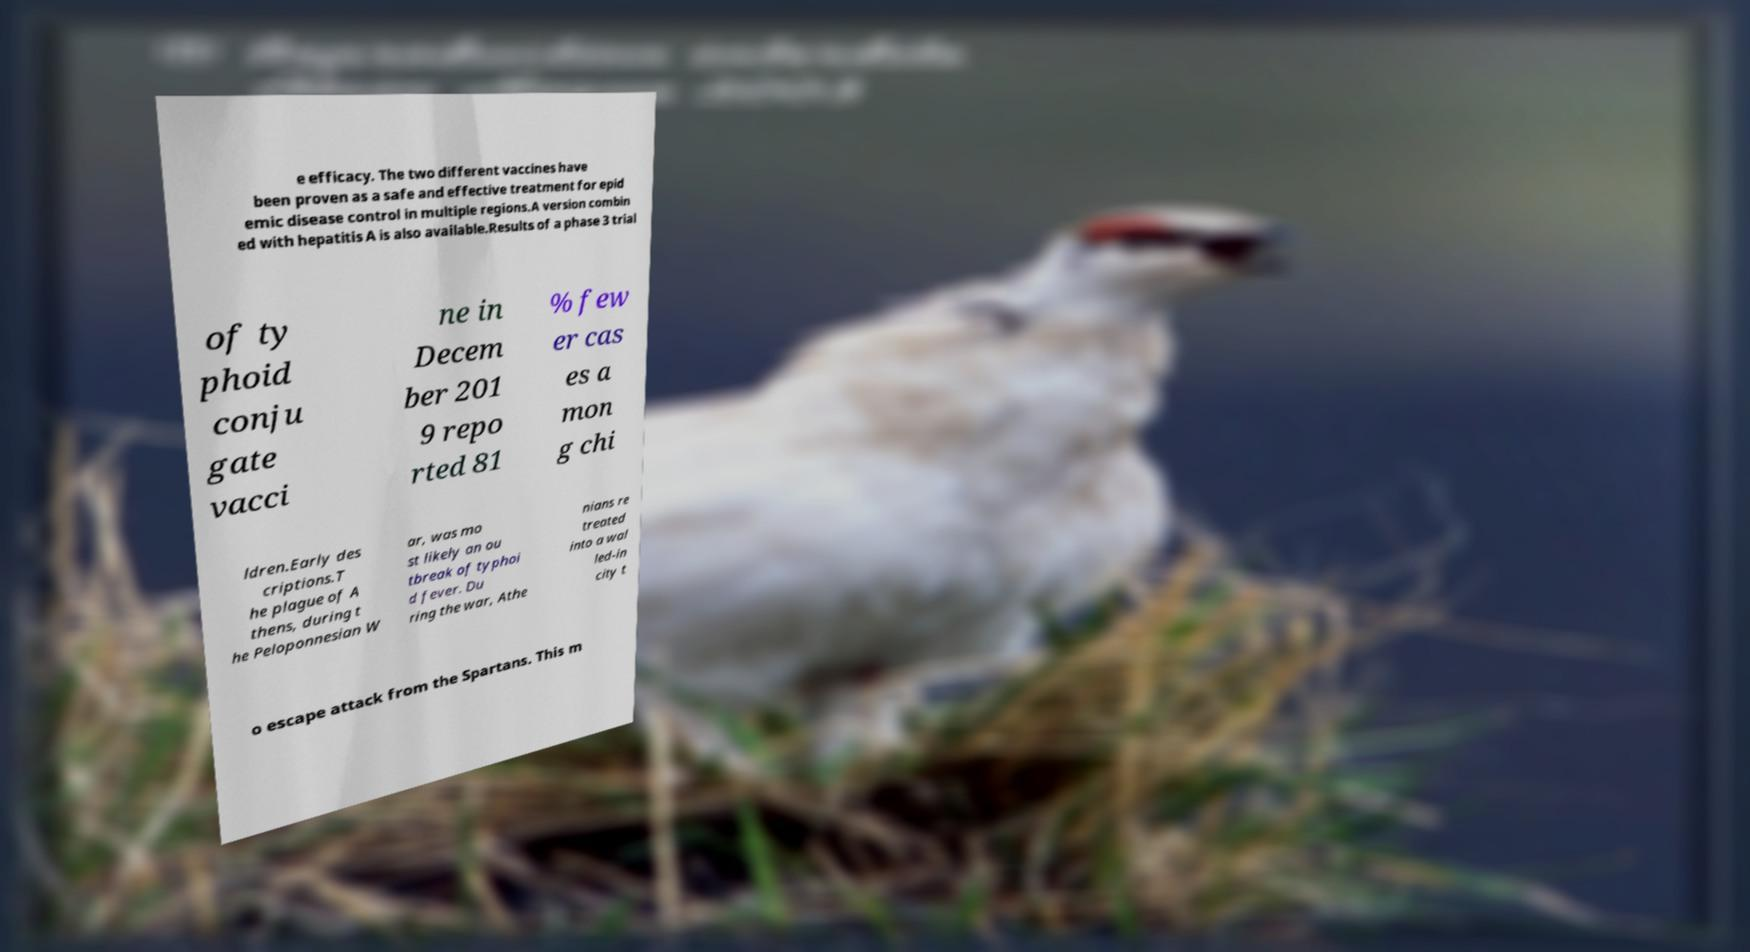Please read and relay the text visible in this image. What does it say? e efficacy. The two different vaccines have been proven as a safe and effective treatment for epid emic disease control in multiple regions.A version combin ed with hepatitis A is also available.Results of a phase 3 trial of ty phoid conju gate vacci ne in Decem ber 201 9 repo rted 81 % few er cas es a mon g chi ldren.Early des criptions.T he plague of A thens, during t he Peloponnesian W ar, was mo st likely an ou tbreak of typhoi d fever. Du ring the war, Athe nians re treated into a wal led-in city t o escape attack from the Spartans. This m 